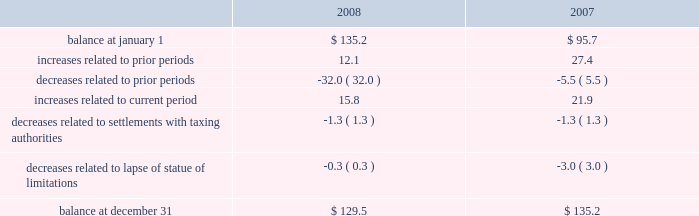Reinvested for continued use in foreign operations .
If the total undistributed earnings of foreign subsidiaries were remitted , a significant amount of the additional tax would be offset by the allowable foreign tax credits .
It is not practical for us to determine the additional tax of remitting these earnings .
In september 2007 , we reached a settlement with the united states department of justice to resolve an investigation into financial relationships between major orthopaedic manufacturers and consulting orthopaedic surgeons .
Under the terms of the settlement , we paid a civil settlement amount of $ 169.5 million and we recorded an expense in that amount .
At the time , no tax benefit was recorded related to the settlement expense due to the uncertainty as to the tax treatment .
During the third quarter of 2008 , we reached an agreement with the u.s .
Internal revenue service ( irs ) confirming the deductibility of a portion of the settlement payment .
As a result , during 2008 we recorded a current tax benefit of $ 31.7 million .
In june 2006 , the financial accounting standards board ( fasb ) issued interpretation no .
48 , accounting for uncertainty in income taxes 2013 an interpretation of fasb statement no .
109 , accounting for income taxes ( fin 48 ) .
Fin 48 addresses the determination of whether tax benefits claimed or expected to be claimed on a tax return should be recorded in the financial statements .
Under fin 48 , we may recognize the tax benefit from an uncertain tax position only if it is more likely than not that the tax position will be sustained on examination by the taxing authorities , based on the technical merits of the position .
The tax benefits recognized in the financial statements from such a position should be measured based on the largest benefit that has a greater than fifty percent likelihood of being realized upon ultimate settlement .
Fin 48 also provides guidance on derecognition , classification , interest and penalties on income taxes , accounting in interim periods and requires increased disclosures .
We adopted fin 48 on january 1 , 2007 .
Prior to the adoption of fin 48 we had a long term tax liability for expected settlement of various federal , state and foreign income tax liabilities that was reflected net of the corollary tax impact of these expected settlements of $ 102.1 million , as well as a separate accrued interest liability of $ 1.7 million .
As a result of the adoption of fin 48 , we are required to present the different components of such liability on a gross basis versus the historical net presentation .
The adoption resulted in the financial statement liability for unrecognized tax benefits decreasing by $ 6.4 million as of january 1 , 2007 .
The adoption resulted in this decrease in the liability as well as a reduction to retained earnings of $ 4.8 million , a reduction in goodwill of $ 61.4 million , the establishment of a tax receivable of $ 58.2 million , which was recorded in other current and non-current assets on our consolidated balance sheet , and an increase in an interest/penalty payable of $ 7.9 million , all as of january 1 , 2007 .
Therefore , after the adoption of fin 48 , the amount of unrecognized tax benefits is $ 95.7 million as of january 1 , 2007 .
As of december 31 , 2008 , the amount of unrecognized tax benefits is $ 129.5 million .
Of this amount , $ 45.5 million would impact our effective tax rate if recognized .
$ 38.2 million of the $ 129.5 million liability for unrecognized tax benefits relate to tax positions of acquired entities taken prior to their acquisition by us .
Under fas 141 ( r ) , if these liabilities are settled for different amounts , they will affect the income tax expense in the period of reversal or settlement .
The following is a tabular reconciliation of the total amounts of unrecognized tax benefits ( in millions ) : .
We recognize accrued interest and penalties related to unrecognized tax benefits in income tax expense in the consolidated statements of earnings , which is consistent with the recognition of these items in prior reporting periods .
As of december 31 , 2007 , we recorded a liability of $ 19.6 million for accrued interest and penalties , of which $ 14.7 million would impact our effective tax rate , if recognized .
The amount of this liability is $ 22.9 million as of december 31 , 2008 .
Of this amount , $ 17.1 million would impact our effective tax rate , if recognized .
We expect that the amount of tax liability for unrecognized tax benefits will change in the next twelve months ; however , we do not expect these changes will have a significant impact on our results of operations or financial position .
The u.s .
Federal statute of limitations remains open for the year 2003 and onward .
The u.s .
Federal returns for years 2003 and 2004 are currently under examination by the irs .
On july 15 , 2008 , the irs issued its examination report .
We filed a formal protest on august 15 , 2008 and requested a conference with the appeals office regarding disputed issues .
Although the appeals process could take several years , we do not anticipate resolution of the audit will result in any significant impact on our results of operations , financial position or cash flows .
In addition , for the 1999 tax year of centerpulse , which we acquired in october 2003 , one issue remains in dispute .
State income tax returns are generally subject to examination for a period of 3 to 5 years after filing of the respective return .
The state impact of any federal changes remains subject to examination by various states for a period of up to one year after formal notification to the states .
We have various state income tax returns in the process of examination , administrative appeals or litigation .
It is z i m m e r h o l d i n g s , i n c .
2 0 0 8 f o r m 1 0 - k a n n u a l r e p o r t notes to consolidated financial statements ( continued ) %%transmsg*** transmitting job : c48761 pcn : 057000000 ***%%pcmsg|57 |00010|yes|no|02/24/2009 06:10|0|0|page is valid , no graphics -- color : d| .
What percent of the balance increase in the two periods were from prior periods? 
Rationale: this shows the late inflow from previous operations while its inverse shows the immediate capitalization of operations
Computations: (15.8 + 21.9)
Answer: 37.7. 